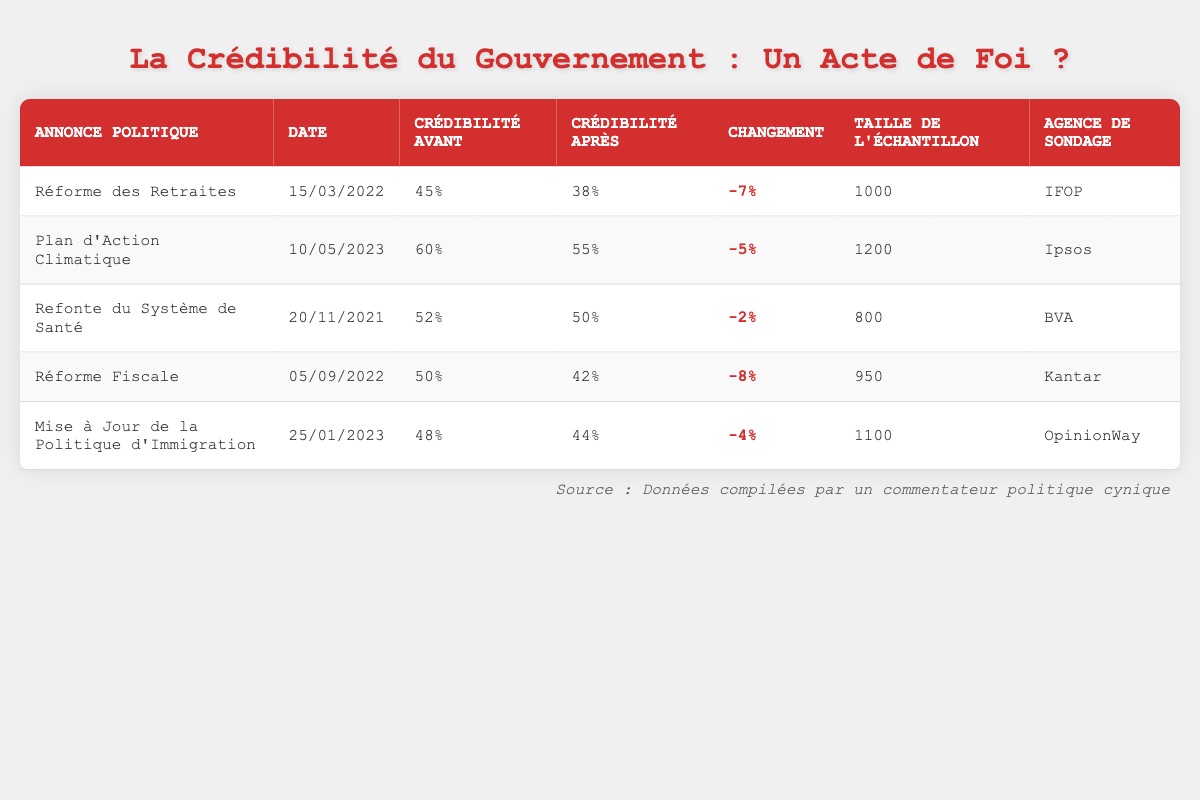What was the credibility before the Pension Reform announcement? The table indicates that the credibility before the Pension Reform announcement was 45%.
Answer: 45% What was the change in credibility for the Tax Reform announcement? The credibility before the Tax Reform was 50% and after it was 42%. Thus, the change is 50% - 42% = 8%, which is a negative change of -8%.
Answer: -8% Did the credibility increase for any of the policy announcements listed in the table? Examining the changes in credibility for each announcement shows that all had a decrease in credibility; none had an increase. Therefore, the answer is no.
Answer: No Which policy announcement had the largest drop in credibility percentage? The largest drop in credibility is for the Tax Reform, which decreased by 8%. This can be seen by comparing the changes across all announcements in the table.
Answer: Tax Reform What is the average credibility before all listed announcements? To find the average credibility before the announcements, we sum the values: (45 + 60 + 52 + 50 + 48) = 255. There are 5 announcements, so the average is 255/5 = 51.
Answer: 51 What percentage of the sample size was recorded by IFOP? The sample size for the Pension Reform announcement, conducted by IFOP, was 1000 out of a total of 1000 + 1200 + 800 + 950 + 1100 = 4150 respondents. The percentage is (1000/4150) * 100 = approximately 24.1%.
Answer: 24.1% Which polling agency recorded the highest credibility before a policy announcement? Reviewing the table, Ipsos recorded the highest credibility before a policy announcement at 60% for the Climate Action Plan.
Answer: Ipsos Was any policy announced on or after January 1, 2023, with a credibility after lower than 50%? Looking at the announcements from January 1, 2023, and later, we find the Climate Action Plan and Immigration Policy had credibility after values of 55% and 44%, respectively; thus, the Immigration Policy is the one below 50%.
Answer: Yes 